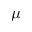<formula> <loc_0><loc_0><loc_500><loc_500>\mu</formula> 